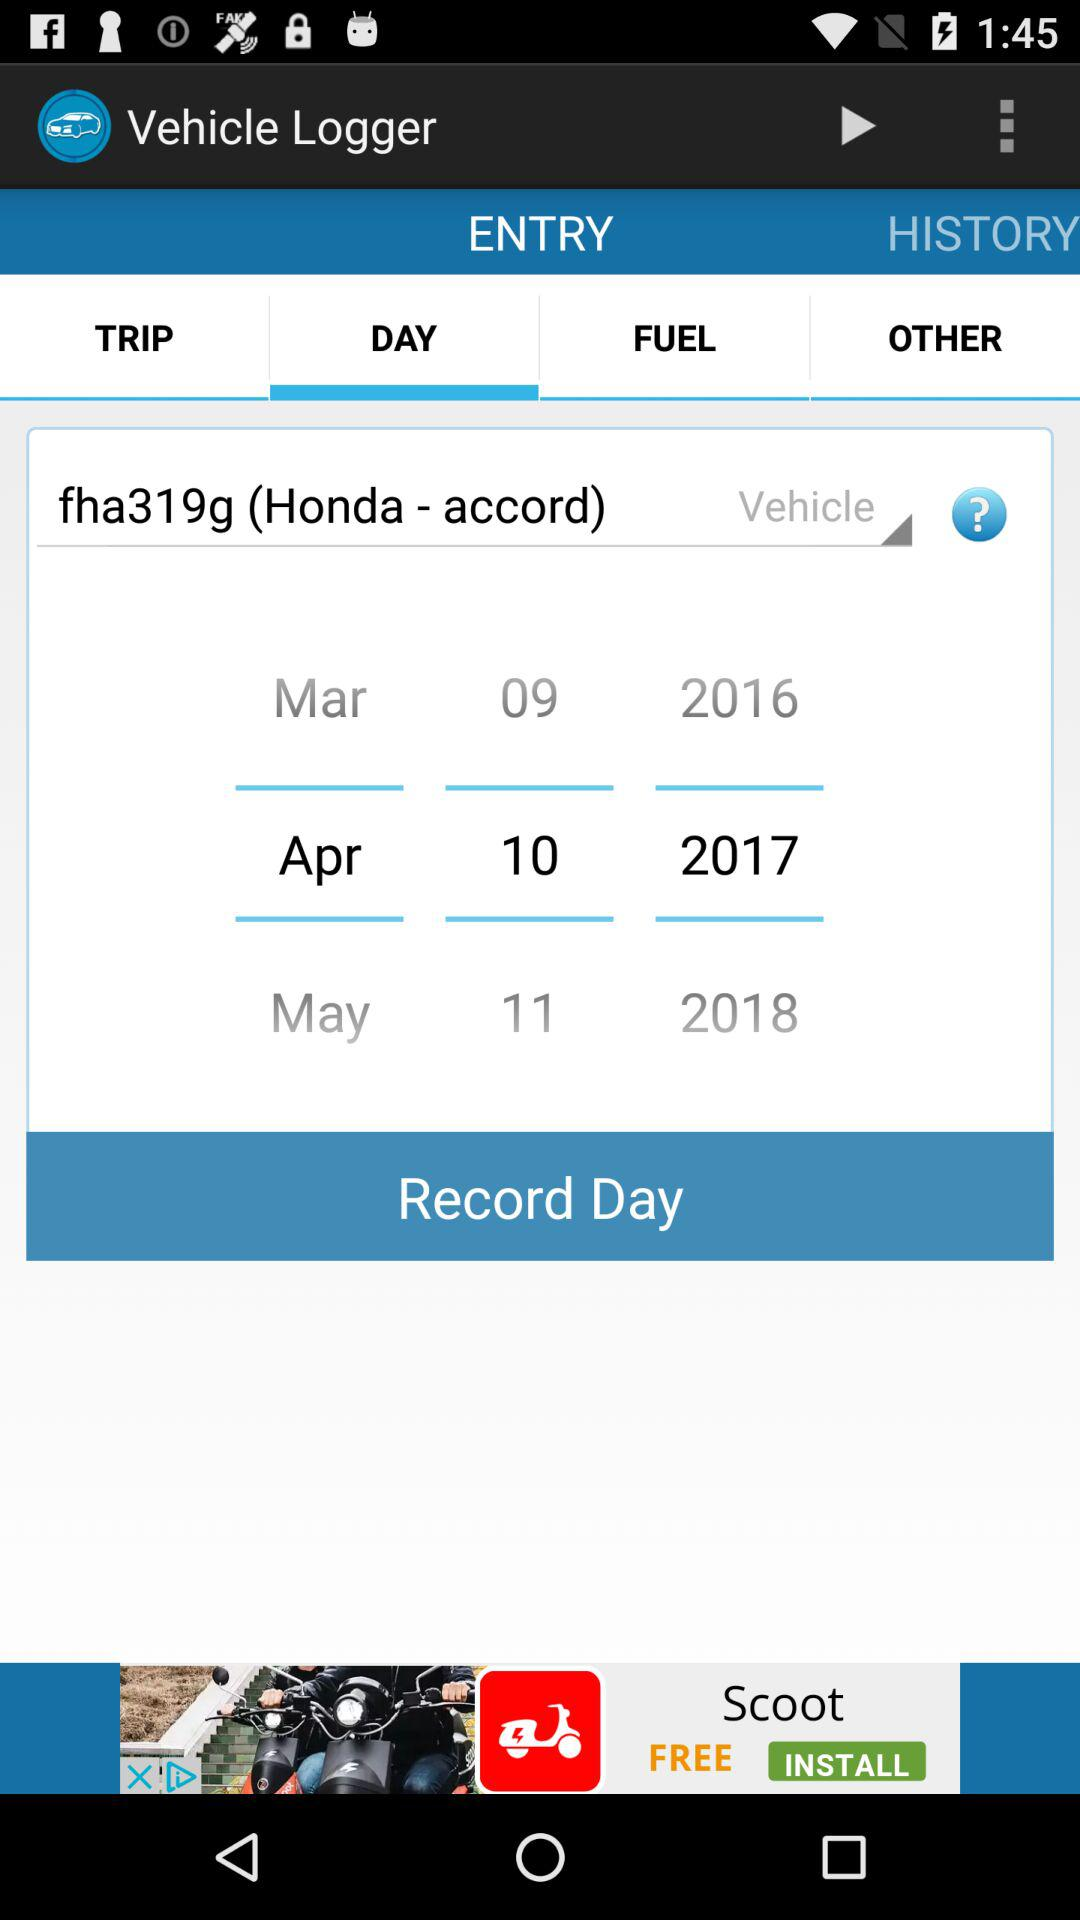Which tab is selected? The selected tabs are "ENTRY" and "DAY". 